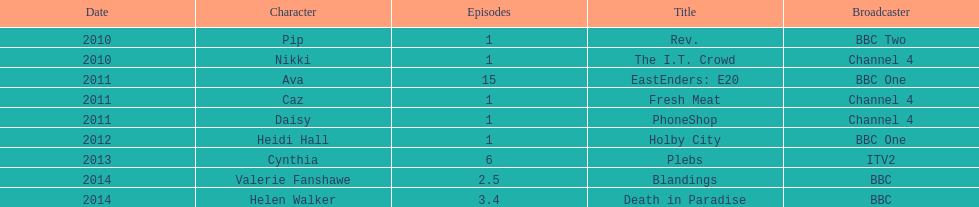What is the total number of shows sophie colguhoun appeared in? 9. 